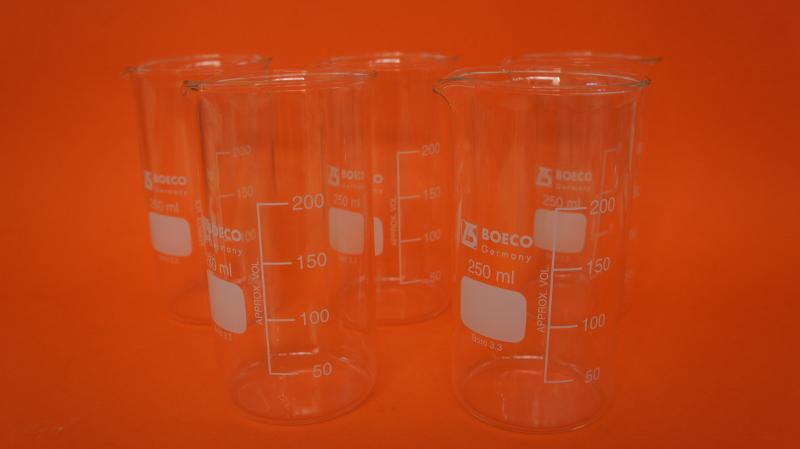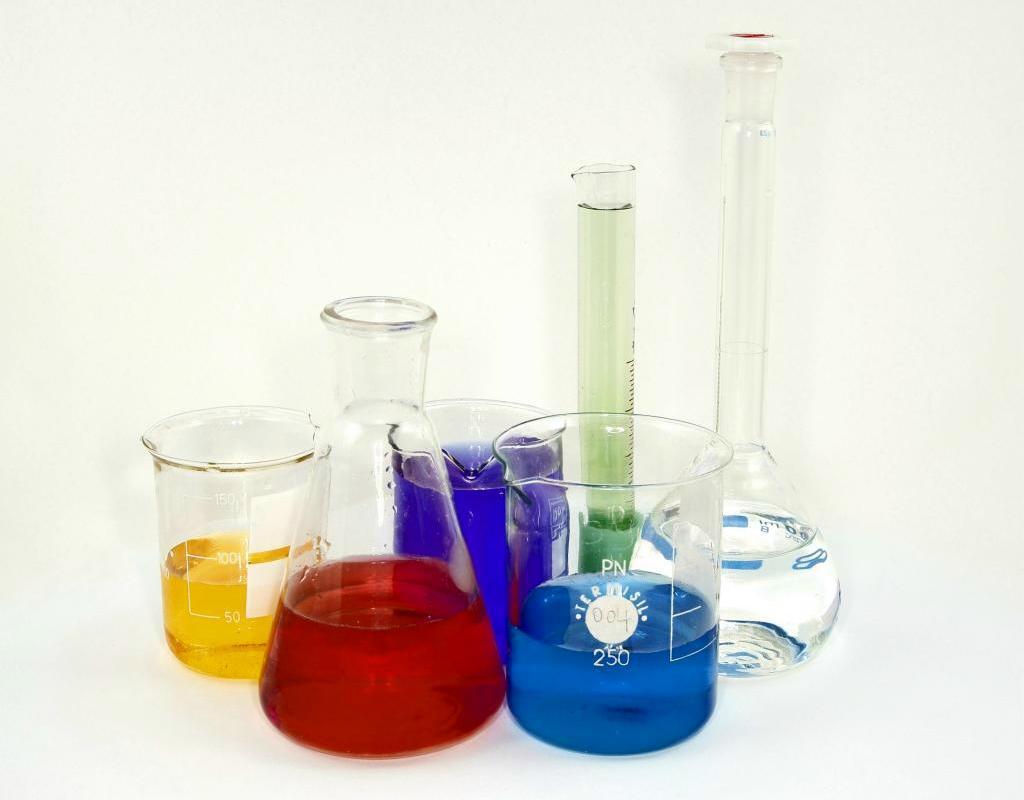The first image is the image on the left, the second image is the image on the right. Assess this claim about the two images: "There are at most 3 laboratory flasks in the left image.". Correct or not? Answer yes or no. No. The first image is the image on the left, the second image is the image on the right. Considering the images on both sides, is "An image shows beakers containing multiple liquid colors, including red, yellow, and blue." valid? Answer yes or no. Yes. 